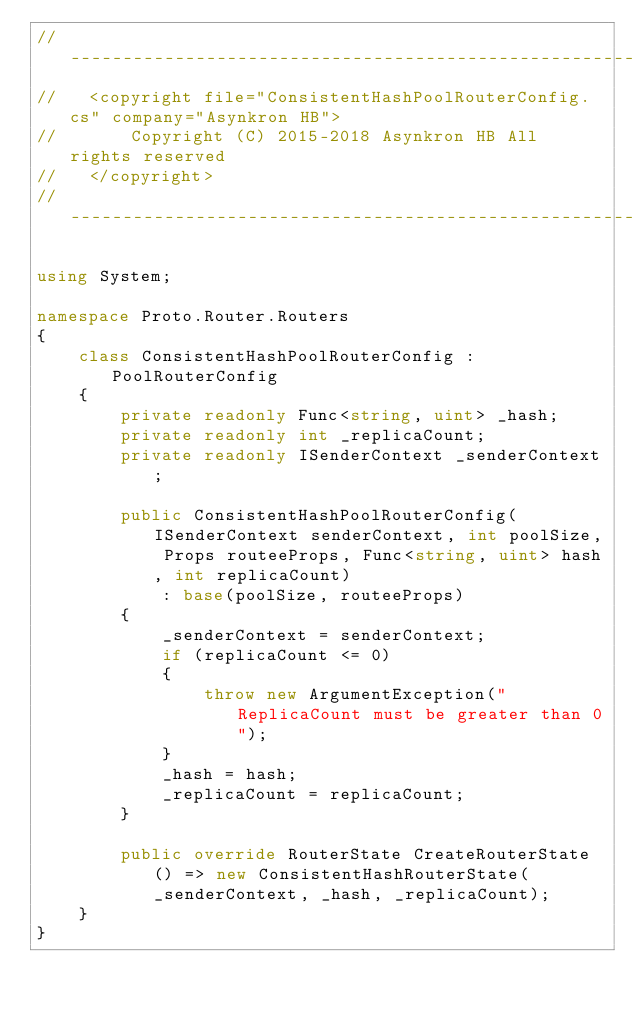Convert code to text. <code><loc_0><loc_0><loc_500><loc_500><_C#_>// -----------------------------------------------------------------------
//   <copyright file="ConsistentHashPoolRouterConfig.cs" company="Asynkron HB">
//       Copyright (C) 2015-2018 Asynkron HB All rights reserved
//   </copyright>
// -----------------------------------------------------------------------

using System;

namespace Proto.Router.Routers
{
    class ConsistentHashPoolRouterConfig : PoolRouterConfig
    {
        private readonly Func<string, uint> _hash;
        private readonly int _replicaCount;
        private readonly ISenderContext _senderContext;

        public ConsistentHashPoolRouterConfig(ISenderContext senderContext, int poolSize, Props routeeProps, Func<string, uint> hash, int replicaCount)
            : base(poolSize, routeeProps)
        {
            _senderContext = senderContext;
            if (replicaCount <= 0)
            {
                throw new ArgumentException("ReplicaCount must be greater than 0");
            }
            _hash = hash;
            _replicaCount = replicaCount;
        }

        public override RouterState CreateRouterState() => new ConsistentHashRouterState(_senderContext, _hash, _replicaCount);
    }
}</code> 